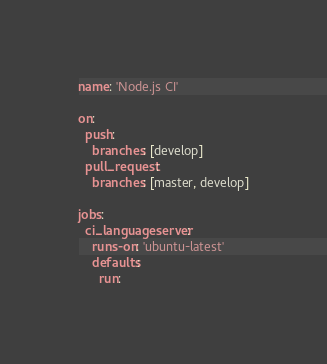Convert code to text. <code><loc_0><loc_0><loc_500><loc_500><_YAML_>name: 'Node.js CI'

on:
  push:
    branches: [develop]
  pull_request:
    branches: [master, develop]

jobs:
  ci_languageserver:
    runs-on: 'ubuntu-latest'
    defaults:
      run:</code> 